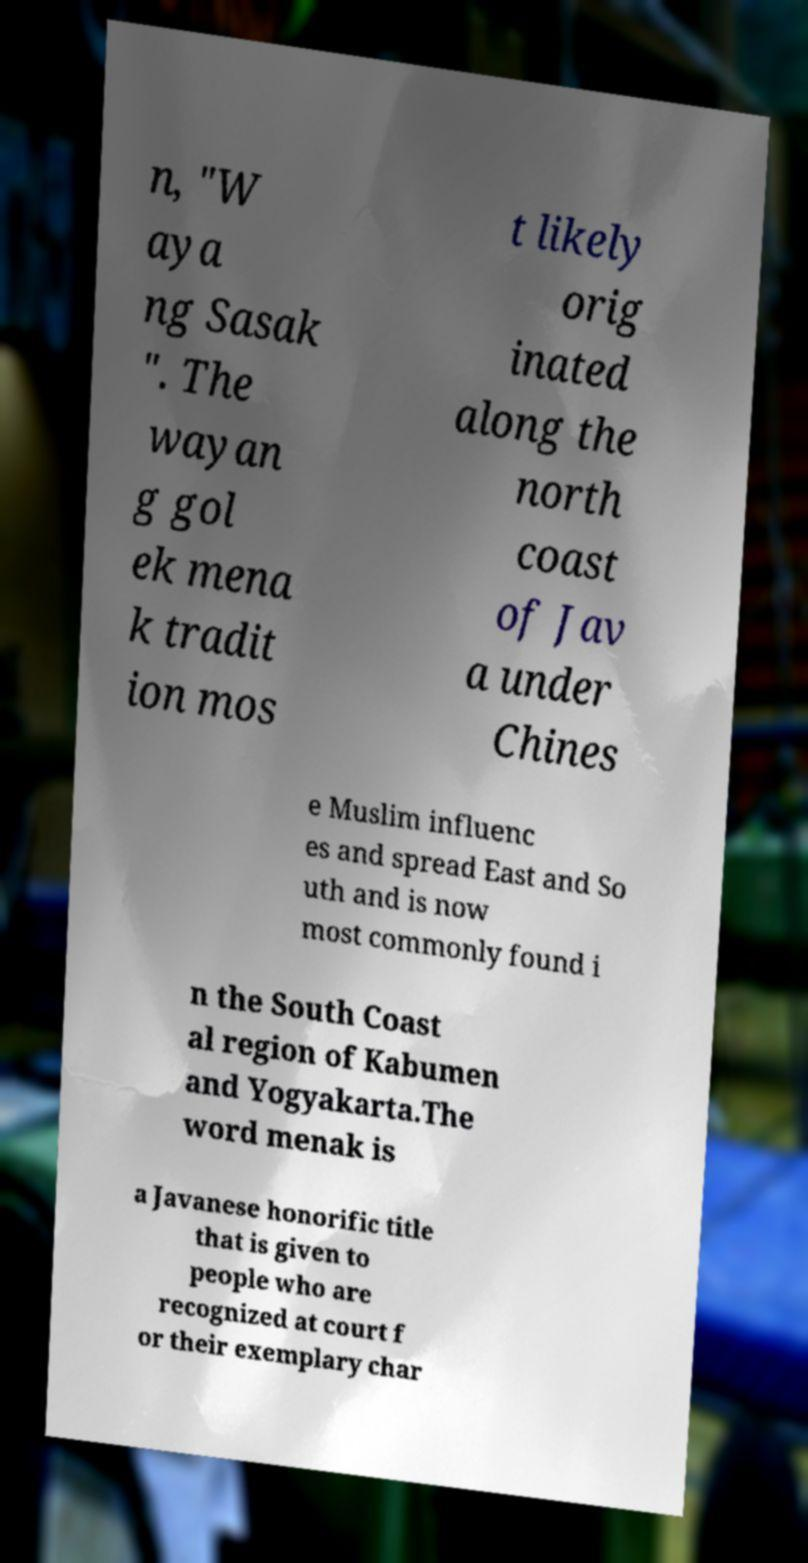I need the written content from this picture converted into text. Can you do that? n, "W aya ng Sasak ". The wayan g gol ek mena k tradit ion mos t likely orig inated along the north coast of Jav a under Chines e Muslim influenc es and spread East and So uth and is now most commonly found i n the South Coast al region of Kabumen and Yogyakarta.The word menak is a Javanese honorific title that is given to people who are recognized at court f or their exemplary char 